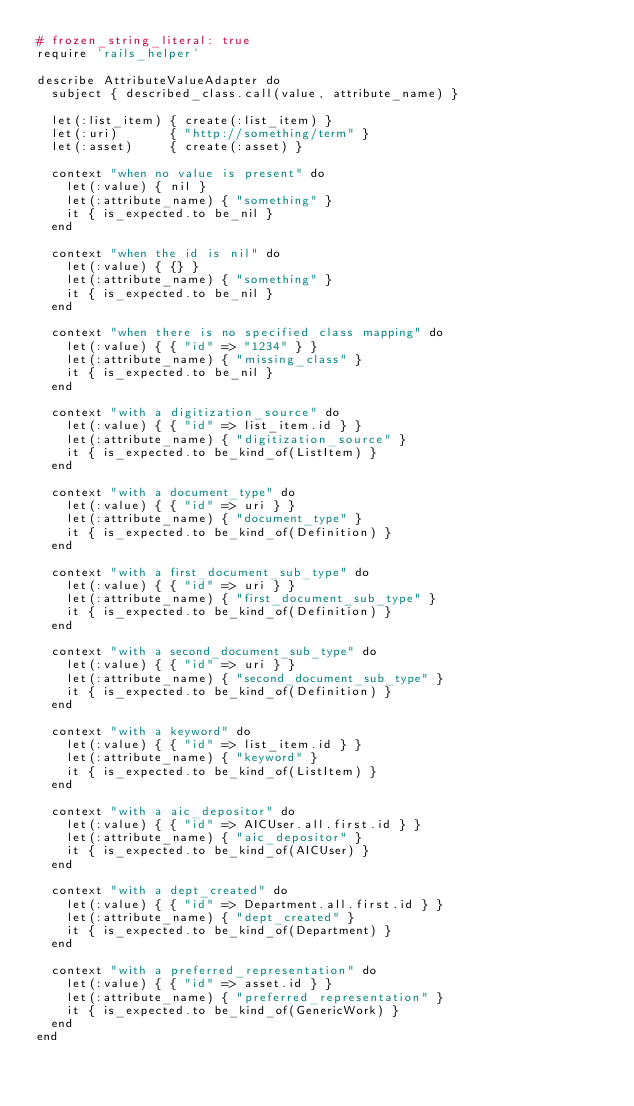<code> <loc_0><loc_0><loc_500><loc_500><_Ruby_># frozen_string_literal: true
require 'rails_helper'

describe AttributeValueAdapter do
  subject { described_class.call(value, attribute_name) }

  let(:list_item) { create(:list_item) }
  let(:uri)       { "http://something/term" }
  let(:asset)     { create(:asset) }

  context "when no value is present" do
    let(:value) { nil }
    let(:attribute_name) { "something" }
    it { is_expected.to be_nil }
  end

  context "when the id is nil" do
    let(:value) { {} }
    let(:attribute_name) { "something" }
    it { is_expected.to be_nil }
  end

  context "when there is no specified class mapping" do
    let(:value) { { "id" => "1234" } }
    let(:attribute_name) { "missing_class" }
    it { is_expected.to be_nil }
  end

  context "with a digitization_source" do
    let(:value) { { "id" => list_item.id } }
    let(:attribute_name) { "digitization_source" }
    it { is_expected.to be_kind_of(ListItem) }
  end

  context "with a document_type" do
    let(:value) { { "id" => uri } }
    let(:attribute_name) { "document_type" }
    it { is_expected.to be_kind_of(Definition) }
  end

  context "with a first_document_sub_type" do
    let(:value) { { "id" => uri } }
    let(:attribute_name) { "first_document_sub_type" }
    it { is_expected.to be_kind_of(Definition) }
  end

  context "with a second_document_sub_type" do
    let(:value) { { "id" => uri } }
    let(:attribute_name) { "second_document_sub_type" }
    it { is_expected.to be_kind_of(Definition) }
  end

  context "with a keyword" do
    let(:value) { { "id" => list_item.id } }
    let(:attribute_name) { "keyword" }
    it { is_expected.to be_kind_of(ListItem) }
  end

  context "with a aic_depositor" do
    let(:value) { { "id" => AICUser.all.first.id } }
    let(:attribute_name) { "aic_depositor" }
    it { is_expected.to be_kind_of(AICUser) }
  end

  context "with a dept_created" do
    let(:value) { { "id" => Department.all.first.id } }
    let(:attribute_name) { "dept_created" }
    it { is_expected.to be_kind_of(Department) }
  end

  context "with a preferred_representation" do
    let(:value) { { "id" => asset.id } }
    let(:attribute_name) { "preferred_representation" }
    it { is_expected.to be_kind_of(GenericWork) }
  end
end
</code> 